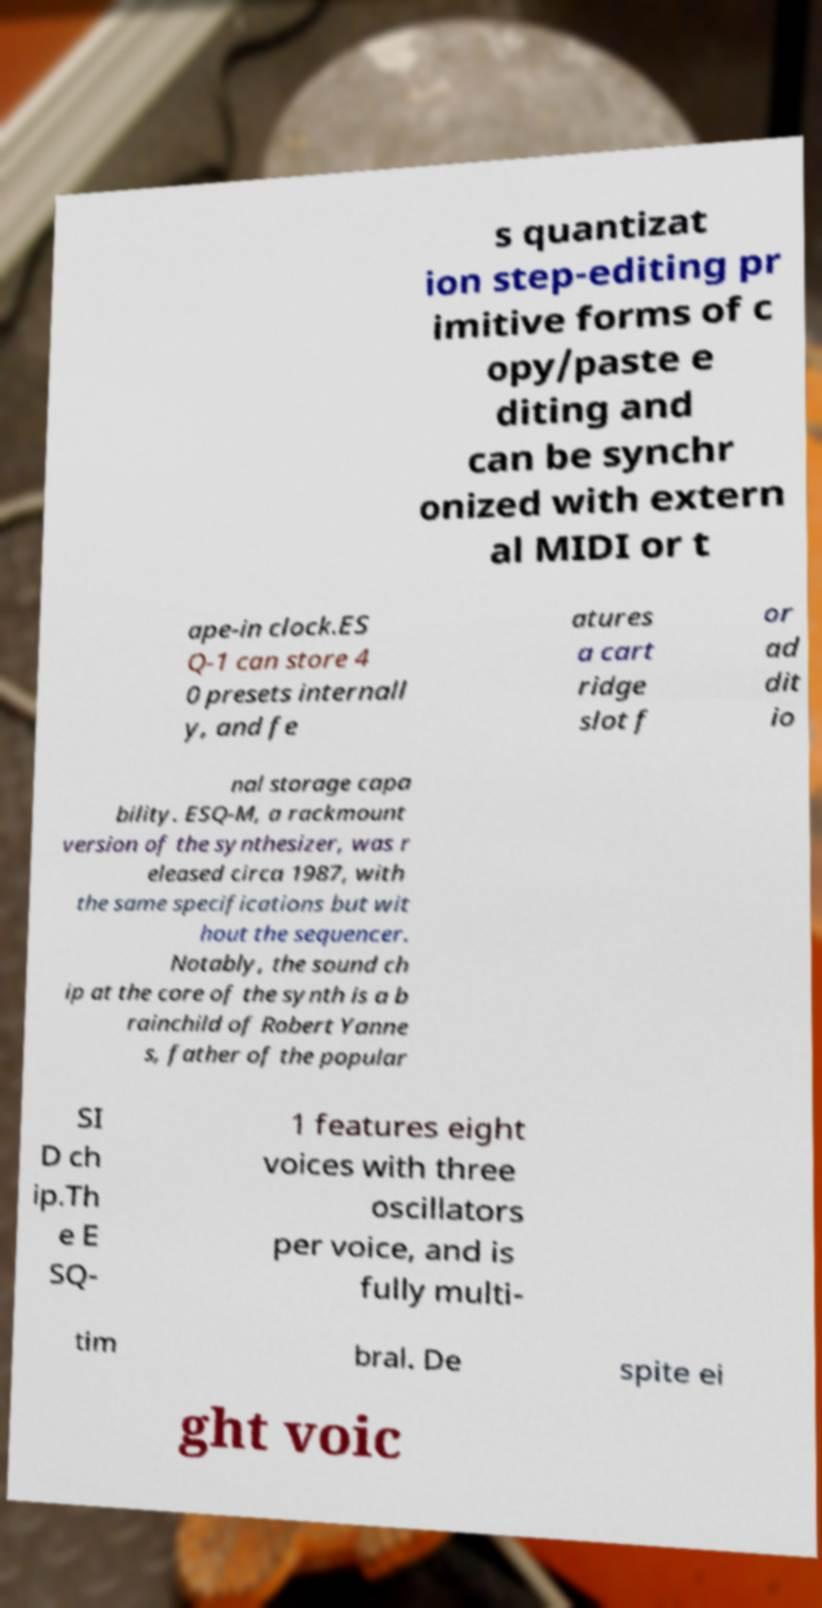Could you assist in decoding the text presented in this image and type it out clearly? s quantizat ion step-editing pr imitive forms of c opy/paste e diting and can be synchr onized with extern al MIDI or t ape-in clock.ES Q-1 can store 4 0 presets internall y, and fe atures a cart ridge slot f or ad dit io nal storage capa bility. ESQ-M, a rackmount version of the synthesizer, was r eleased circa 1987, with the same specifications but wit hout the sequencer. Notably, the sound ch ip at the core of the synth is a b rainchild of Robert Yanne s, father of the popular SI D ch ip.Th e E SQ- 1 features eight voices with three oscillators per voice, and is fully multi- tim bral. De spite ei ght voic 